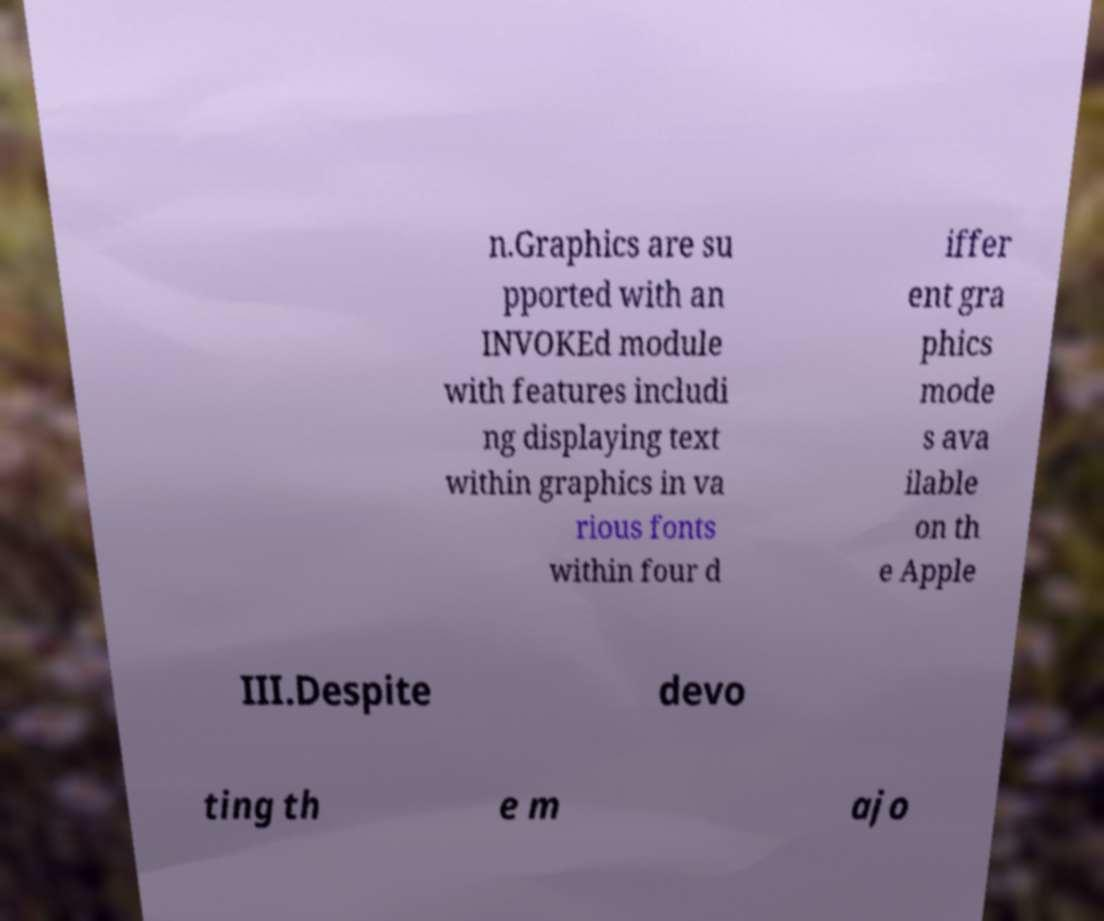Can you accurately transcribe the text from the provided image for me? n.Graphics are su pported with an INVOKEd module with features includi ng displaying text within graphics in va rious fonts within four d iffer ent gra phics mode s ava ilable on th e Apple III.Despite devo ting th e m ajo 